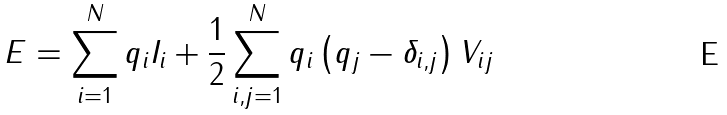Convert formula to latex. <formula><loc_0><loc_0><loc_500><loc_500>E = \sum _ { i = 1 } ^ { N } q _ { i } I _ { i } + \frac { 1 } { 2 } \sum _ { i , j = 1 } ^ { N } q _ { i } \left ( q _ { j } - \delta _ { i , j } \right ) V _ { i j }</formula> 